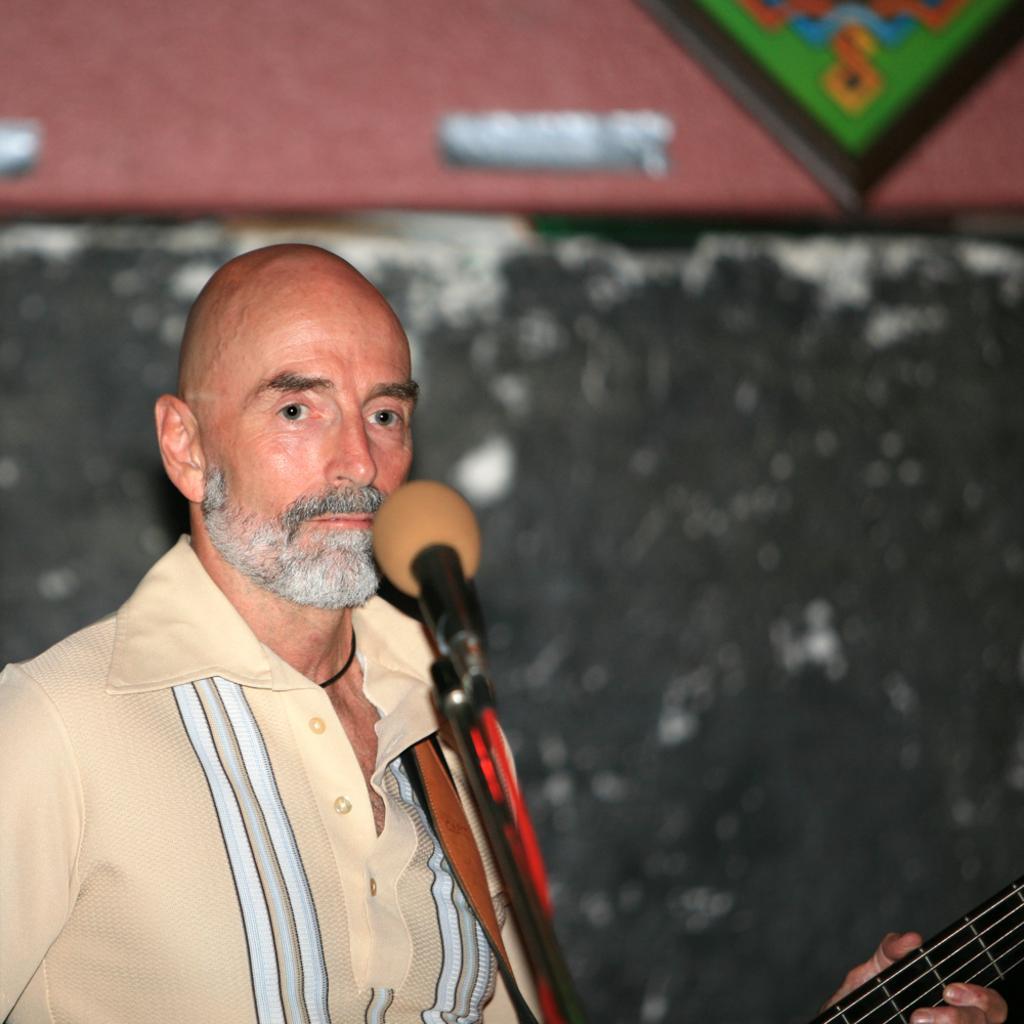Describe this image in one or two sentences. In this image on the left side there is one person in front of him there is one mike. On the background there is a wall, it seems that this person is holding a guitar. 